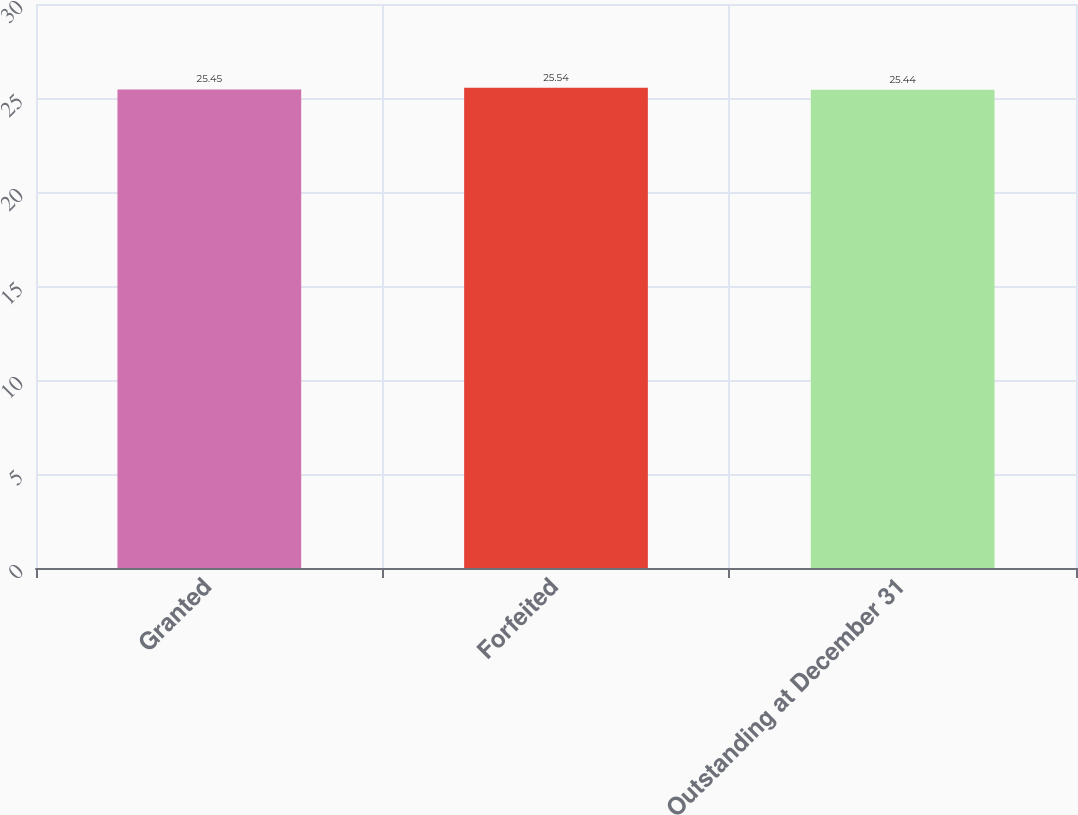<chart> <loc_0><loc_0><loc_500><loc_500><bar_chart><fcel>Granted<fcel>Forfeited<fcel>Outstanding at December 31<nl><fcel>25.45<fcel>25.54<fcel>25.44<nl></chart> 